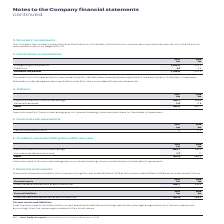According to Auto Trader's financial document, What characteristics do amounts owed by Group undertakings possess? non-interest-bearing, unsecured and have no fixed date of repayment. The document states: "Amounts owed by Group undertakings are non-interest-bearing, unsecured and have no fixed date of repayment...." Also, What was the total amount owed to debtors by the Group in 2019? According to the financial document, 415.9 (in millions). The relevant text states: "Total 415.9 440.7..." Also, What are the components factored in when calculating the total amount owed to debtors in the table? The document shows two values: Amounts owed by Group undertakings and Deferred tax asset. From the document: "Deferred tax asset 1.2 0.8 Amounts owed by Group undertakings 414.7 439.9..." Additionally, In which year was the Deferred tax asset larger? According to the financial document, 2019. The relevant text states: "2019 £m 2018 £m..." Also, can you calculate: What was the change in deferred tax asset in 2019 from 2018? Based on the calculation: 1.2-0.8, the result is 0.4 (in millions). This is based on the information: "Deferred tax asset 1.2 0.8 Deferred tax asset 1.2 0.8..." The key data points involved are: 0.8, 1.2. Also, can you calculate: What was the percentage change in deferred tax asset in 2019 from 2018? To answer this question, I need to perform calculations using the financial data. The calculation is: (1.2-0.8)/0.8, which equals 50 (percentage). This is based on the information: "Deferred tax asset 1.2 0.8 Deferred tax asset 1.2 0.8..." The key data points involved are: 0.8, 1.2. 